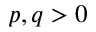<formula> <loc_0><loc_0><loc_500><loc_500>p , q > 0</formula> 